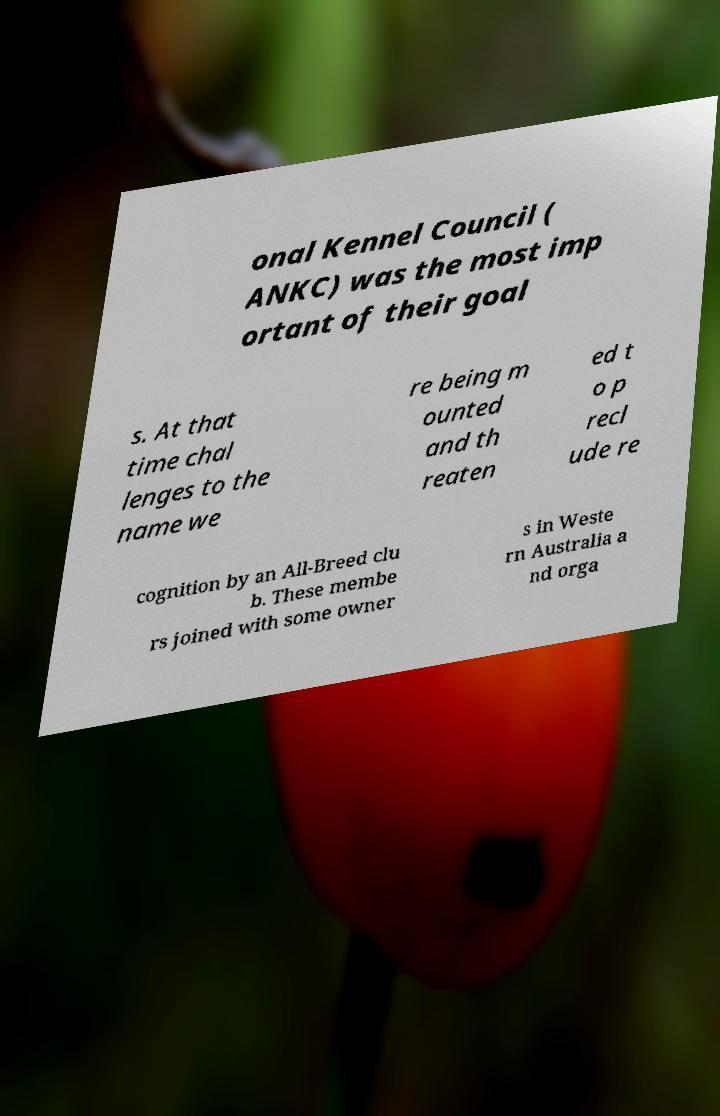What messages or text are displayed in this image? I need them in a readable, typed format. onal Kennel Council ( ANKC) was the most imp ortant of their goal s. At that time chal lenges to the name we re being m ounted and th reaten ed t o p recl ude re cognition by an All-Breed clu b. These membe rs joined with some owner s in Weste rn Australia a nd orga 